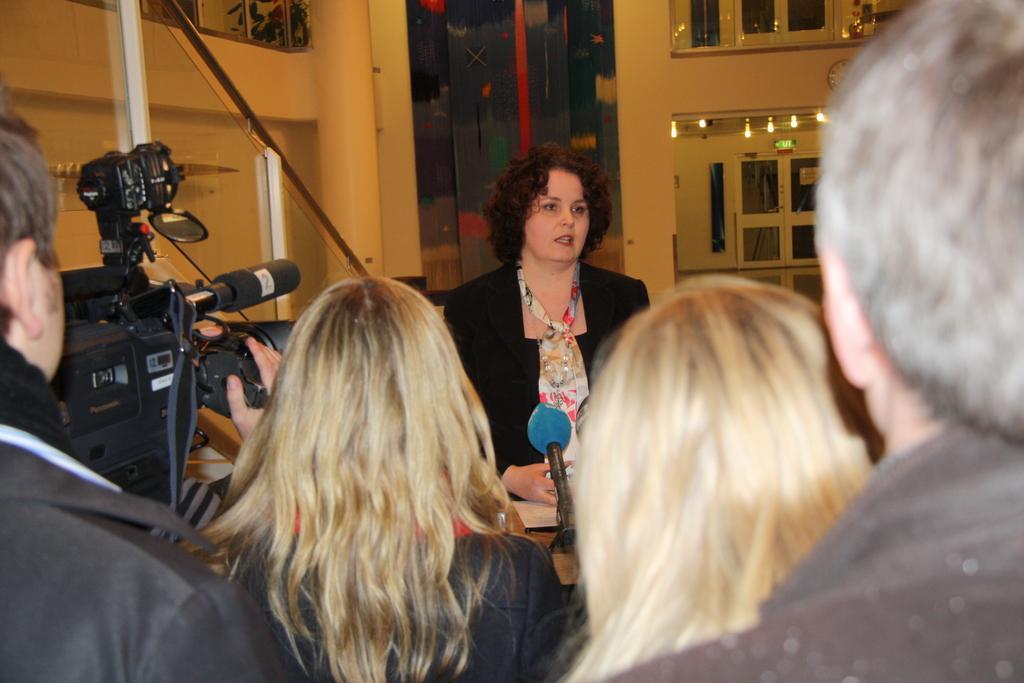How would you summarize this image in a sentence or two? In this picture there are people, among them there is a person holding a camera and we can see microphone on the podium. In the background of the image we can see wall, lights and railing. 